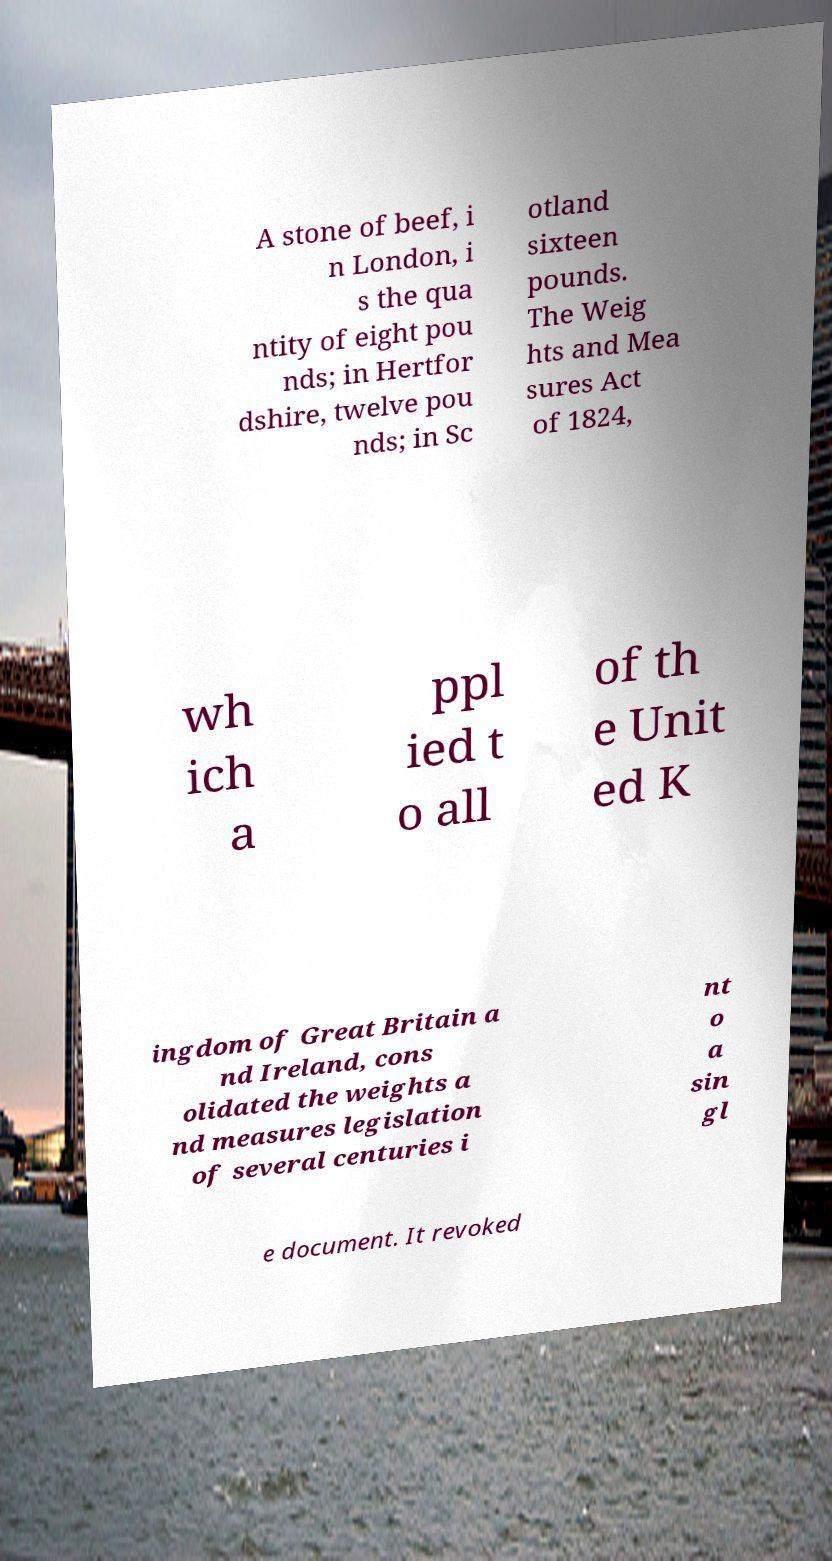Could you assist in decoding the text presented in this image and type it out clearly? A stone of beef, i n London, i s the qua ntity of eight pou nds; in Hertfor dshire, twelve pou nds; in Sc otland sixteen pounds. The Weig hts and Mea sures Act of 1824, wh ich a ppl ied t o all of th e Unit ed K ingdom of Great Britain a nd Ireland, cons olidated the weights a nd measures legislation of several centuries i nt o a sin gl e document. It revoked 